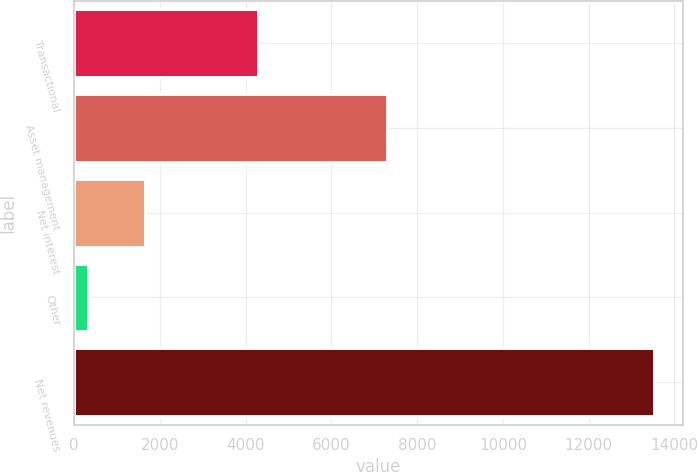Convert chart. <chart><loc_0><loc_0><loc_500><loc_500><bar_chart><fcel>Transactional<fcel>Asset management<fcel>Net interest<fcel>Other<fcel>Net revenues<nl><fcel>4290<fcel>7288<fcel>1645<fcel>326<fcel>13516<nl></chart> 